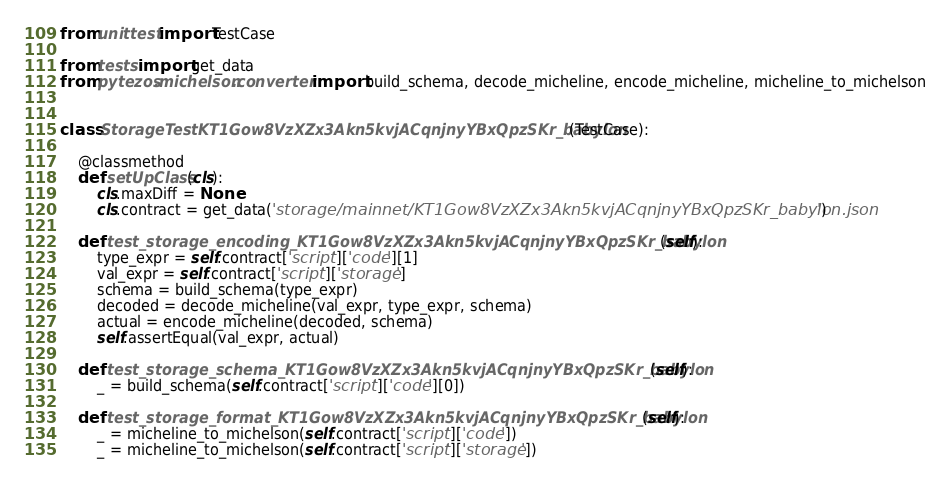Convert code to text. <code><loc_0><loc_0><loc_500><loc_500><_Python_>from unittest import TestCase

from tests import get_data
from pytezos.michelson.converter import build_schema, decode_micheline, encode_micheline, micheline_to_michelson


class StorageTestKT1Gow8VzXZx3Akn5kvjACqnjnyYBxQpzSKr_babylon(TestCase):

    @classmethod
    def setUpClass(cls):
        cls.maxDiff = None
        cls.contract = get_data('storage/mainnet/KT1Gow8VzXZx3Akn5kvjACqnjnyYBxQpzSKr_babylon.json')

    def test_storage_encoding_KT1Gow8VzXZx3Akn5kvjACqnjnyYBxQpzSKr_babylon(self):
        type_expr = self.contract['script']['code'][1]
        val_expr = self.contract['script']['storage']
        schema = build_schema(type_expr)
        decoded = decode_micheline(val_expr, type_expr, schema)
        actual = encode_micheline(decoded, schema)
        self.assertEqual(val_expr, actual)

    def test_storage_schema_KT1Gow8VzXZx3Akn5kvjACqnjnyYBxQpzSKr_babylon(self):
        _ = build_schema(self.contract['script']['code'][0])

    def test_storage_format_KT1Gow8VzXZx3Akn5kvjACqnjnyYBxQpzSKr_babylon(self):
        _ = micheline_to_michelson(self.contract['script']['code'])
        _ = micheline_to_michelson(self.contract['script']['storage'])
</code> 